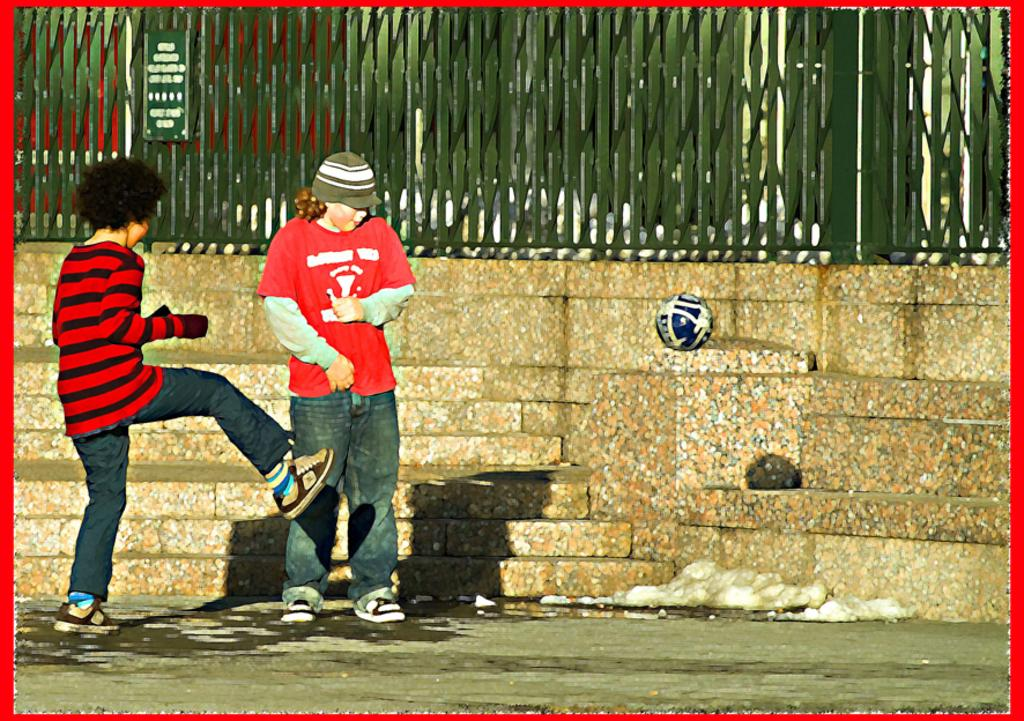How many people are in the image? There are two people standing in the image. What are the people wearing? The people are wearing different color dresses. What can be seen in the background of the image? There is a wall and fencing in the image. What objects are present in the image? There is a board and a ball in the image. Where is the library located in the image? There is no library present in the image. What type of cup is being used by the people in the image? There is no cup visible in the image. 